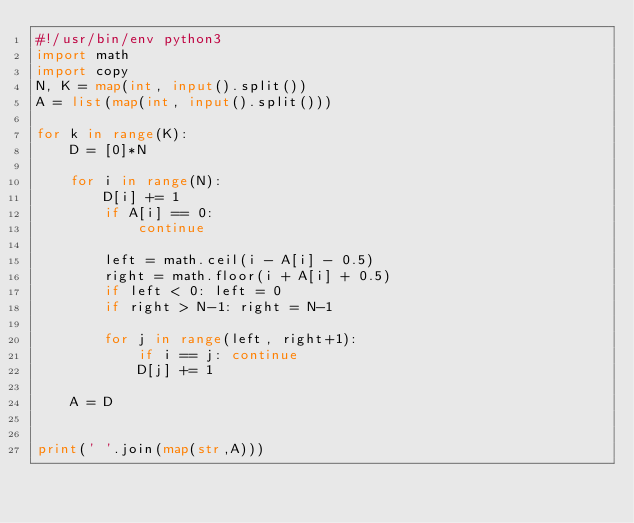<code> <loc_0><loc_0><loc_500><loc_500><_Python_>#!/usr/bin/env python3
import math
import copy
N, K = map(int, input().split())
A = list(map(int, input().split()))

for k in range(K):
    D = [0]*N

    for i in range(N):
        D[i] += 1
        if A[i] == 0:
            continue

        left = math.ceil(i - A[i] - 0.5)
        right = math.floor(i + A[i] + 0.5)
        if left < 0: left = 0
        if right > N-1: right = N-1
    
        for j in range(left, right+1):
            if i == j: continue
            D[j] += 1

    A = D


print(' '.join(map(str,A)))

    
</code> 